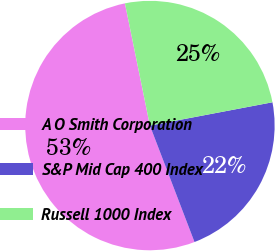Convert chart. <chart><loc_0><loc_0><loc_500><loc_500><pie_chart><fcel>A O Smith Corporation<fcel>S&P Mid Cap 400 Index<fcel>Russell 1000 Index<nl><fcel>52.61%<fcel>22.17%<fcel>25.22%<nl></chart> 